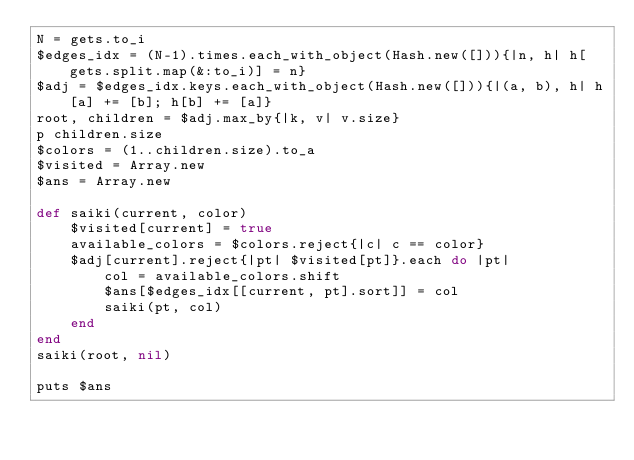<code> <loc_0><loc_0><loc_500><loc_500><_Ruby_>N = gets.to_i
$edges_idx = (N-1).times.each_with_object(Hash.new([])){|n, h| h[gets.split.map(&:to_i)] = n}
$adj = $edges_idx.keys.each_with_object(Hash.new([])){|(a, b), h| h[a] += [b]; h[b] += [a]}
root, children = $adj.max_by{|k, v| v.size}
p children.size
$colors = (1..children.size).to_a
$visited = Array.new
$ans = Array.new

def saiki(current, color)
    $visited[current] = true
    available_colors = $colors.reject{|c| c == color}
    $adj[current].reject{|pt| $visited[pt]}.each do |pt|
        col = available_colors.shift
        $ans[$edges_idx[[current, pt].sort]] = col
        saiki(pt, col)
    end
end
saiki(root, nil)

puts $ans</code> 